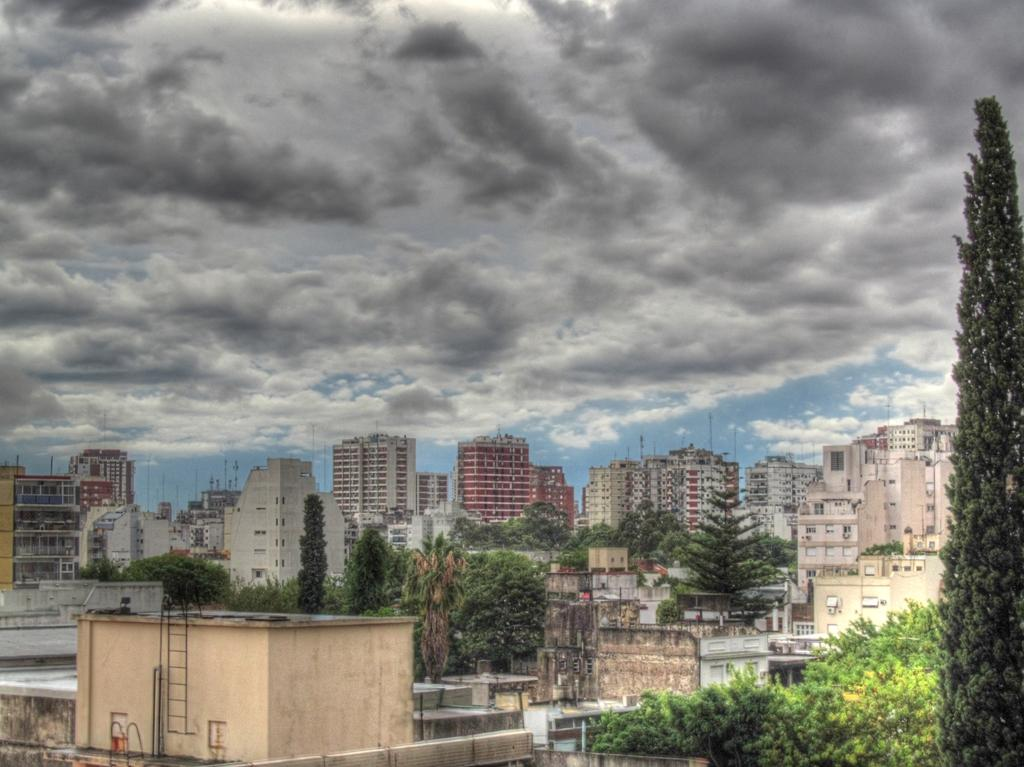What type of structures can be seen in the image? There are buildings in the image. What natural elements are present in the image? There are trees in the image. What man-made objects can be seen in the image? There are poles in the image. What can be seen in the background of the image? There are clouds visible in the background of the image. What level of mindfulness is depicted in the image? There is no indication of mindfulness or any mental state in the image, as it primarily features buildings, trees, poles, and clouds. Can you see any cows in the image? There are no cows present in the image. 